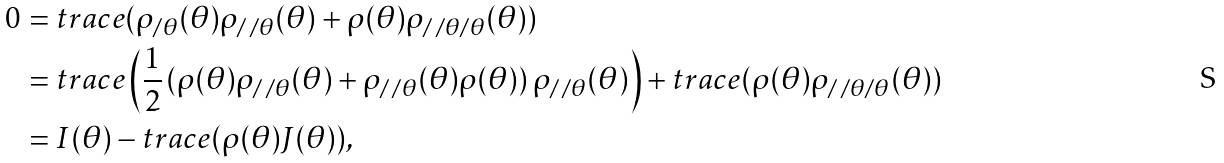<formula> <loc_0><loc_0><loc_500><loc_500>0 & = t r a c e ( \rho _ { / \theta } ( \theta ) \rho _ { / \, / \theta } ( \theta ) + \rho ( \theta ) \rho _ { / \, / \theta / \theta } ( \theta ) ) \\ & = t r a c e \left ( { \frac { 1 } { 2 } } \left ( \rho ( \theta ) \rho _ { / \, / \theta } ( \theta ) + \rho _ { / \, / \theta } ( \theta ) \rho ( \theta ) \right ) \rho _ { / \, / \theta } ( \theta ) \right ) + t r a c e ( \rho ( \theta ) \rho _ { / \, / \theta / \theta } ( \theta ) ) \\ & = I ( \theta ) - t r a c e ( \rho ( \theta ) J ( \theta ) ) ,</formula> 